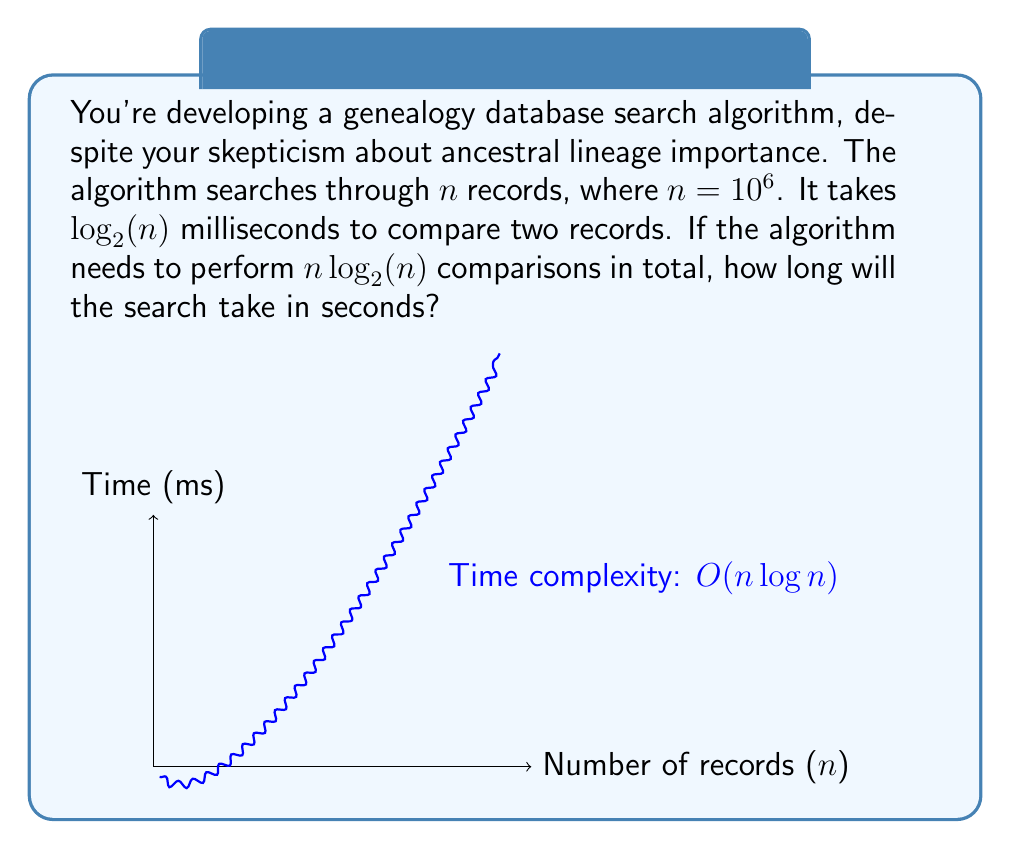Help me with this question. Let's approach this step-by-step:

1) We're given that $n = 10^6$ records.

2) Each comparison takes $\log_2(n)$ milliseconds.

3) The total number of comparisons is $n\log_2(n)$.

4) So, the total time in milliseconds is:
   $$T = (n\log_2(n)) \cdot \log_2(n) = n(\log_2(n))^2$$

5) Substituting $n = 10^6$:
   $$T = 10^6 \cdot (\log_2(10^6))^2$$

6) $\log_2(10^6) = \log_2(10^6) \approx 19.93$

7) Therefore:
   $$T \approx 10^6 \cdot (19.93)^2 \approx 397,200,000 \text{ milliseconds}$$

8) To convert to seconds, divide by 1000:
   $$T \approx 397,200 \text{ seconds}$$
Answer: 397,200 seconds 